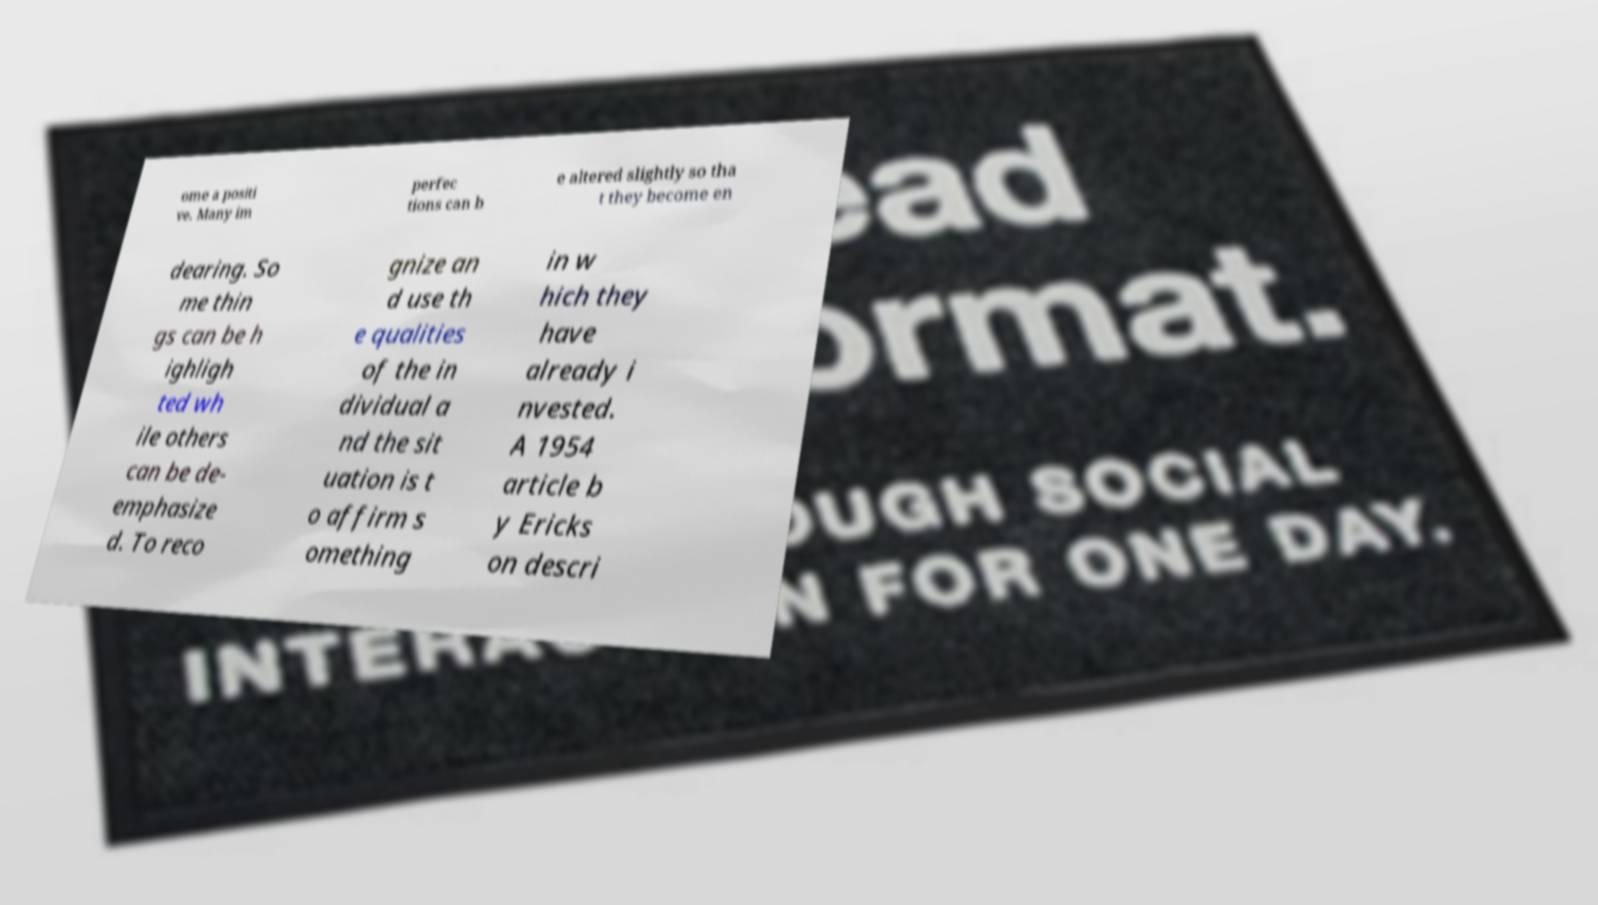There's text embedded in this image that I need extracted. Can you transcribe it verbatim? ome a positi ve. Many im perfec tions can b e altered slightly so tha t they become en dearing. So me thin gs can be h ighligh ted wh ile others can be de- emphasize d. To reco gnize an d use th e qualities of the in dividual a nd the sit uation is t o affirm s omething in w hich they have already i nvested. A 1954 article b y Ericks on descri 